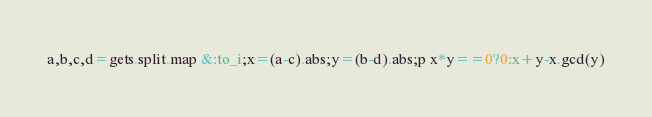Convert code to text. <code><loc_0><loc_0><loc_500><loc_500><_Ruby_>a,b,c,d=gets.split.map &:to_i;x=(a-c).abs;y=(b-d).abs;p x*y==0?0:x+y-x.gcd(y)</code> 